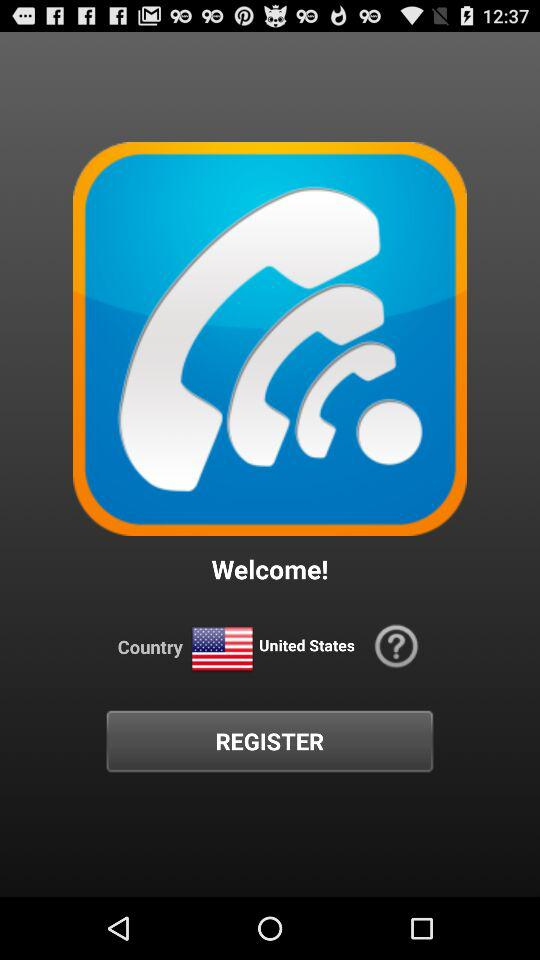What is the country's name? The country's name is the United States. 